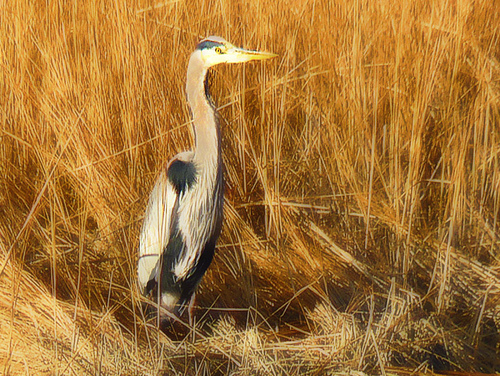<image>
Is the heron in the grass? Yes. The heron is contained within or inside the grass, showing a containment relationship. 